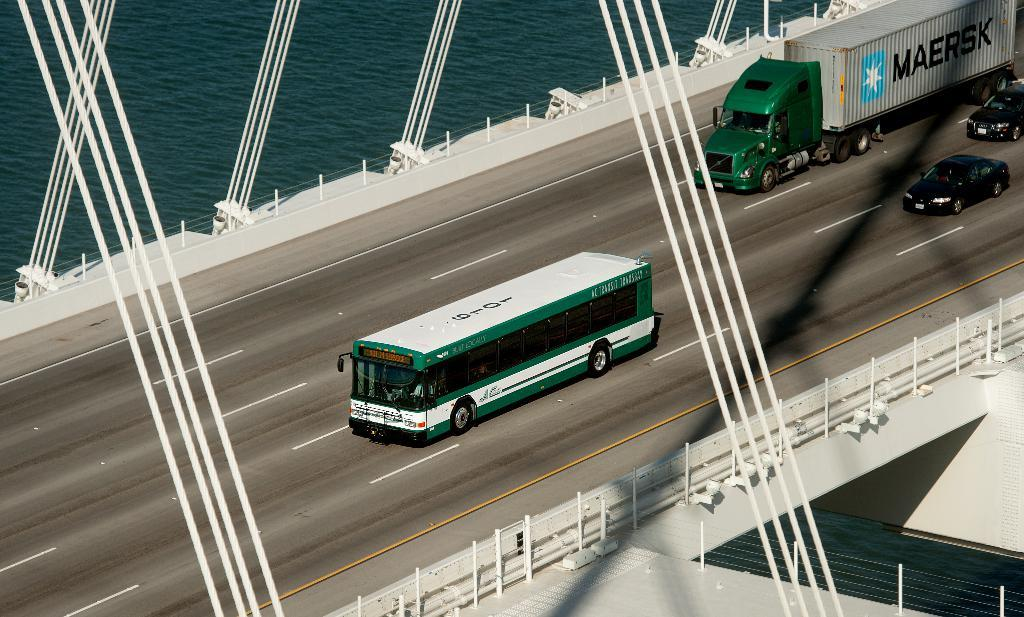What can be seen on the road in the image? There are fleets of vehicles on the road in the image. What type of structure is present in the image? There is a bridge in the image. What material is used for the rods visible in the image? Metal rods are visible in the image. What natural element is present in the image? There is water in the image. Can you determine the time of day the image was taken? The image was likely taken during the day, as there is sufficient light to see the details clearly. Reasoning: Let's think step by step by step in order to produce the conversation. We start by identifying the main subjects and objects in the image based on the provided facts. We then formulate questions that focus on the location and characteristics of these subjects and objects, ensuring that each question can be answered definitively with the information given. We avoid yes/no questions and ensure that the language is simple and clear. Absurd Question/Answer: What type of bucket is used to provide comfort to the skin in the image? There is no bucket or reference to comforting the skin in the image; it features fleets of vehicles, a bridge, metal rods, water, and was likely taken during the day. What type of skin is visible on the metal rods in the image? There is no skin visible on the metal rods in the image; they are simply metal rods. 